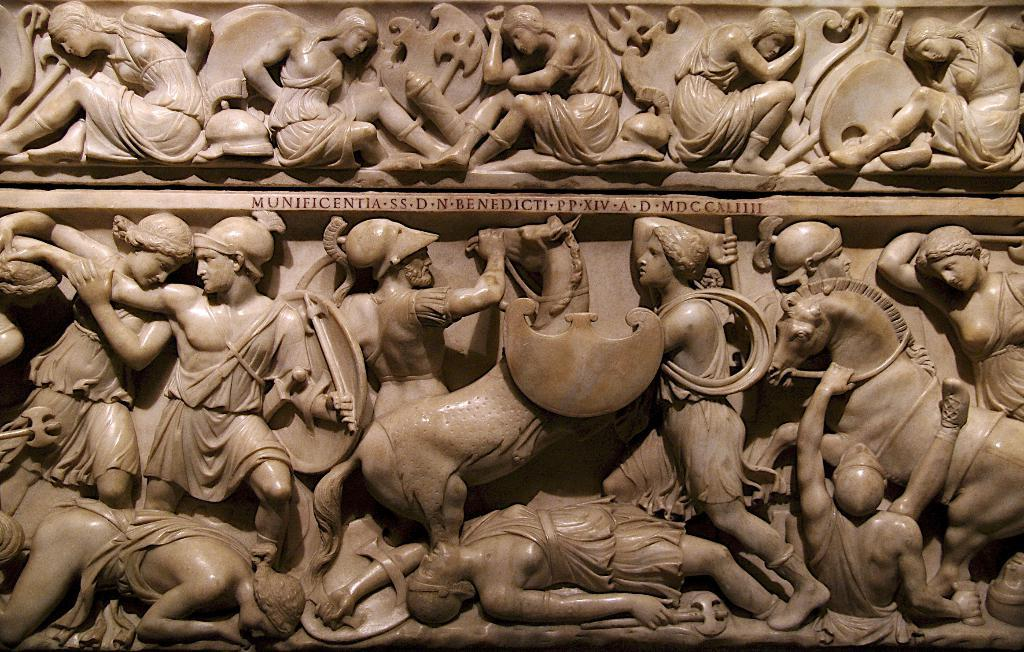What type of art is present in the image? There are sculptures in the image. Where are the sculptures located? The sculptures are on a rock. What type of feather can be seen on the sculptures in the image? There are no feathers present on the sculptures in the image. 